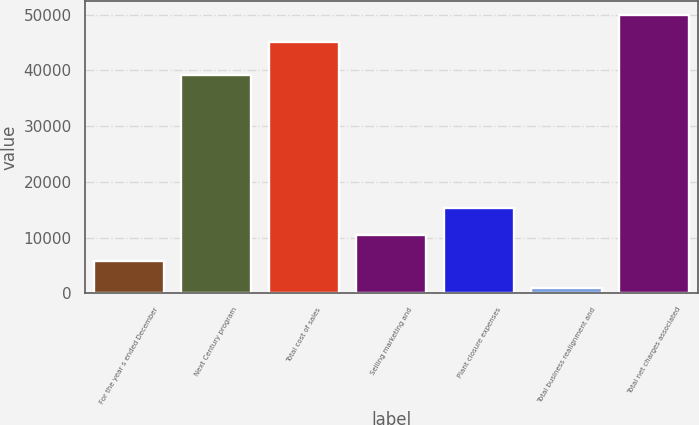<chart> <loc_0><loc_0><loc_500><loc_500><bar_chart><fcel>For the year s ended December<fcel>Next Century program<fcel>Total cost of sales<fcel>Selling marketing and<fcel>Plant closure expenses<fcel>Total business realignment and<fcel>Total net charges associated<nl><fcel>5714.5<fcel>39280<fcel>45096<fcel>10543<fcel>15371.5<fcel>886<fcel>49924.5<nl></chart> 